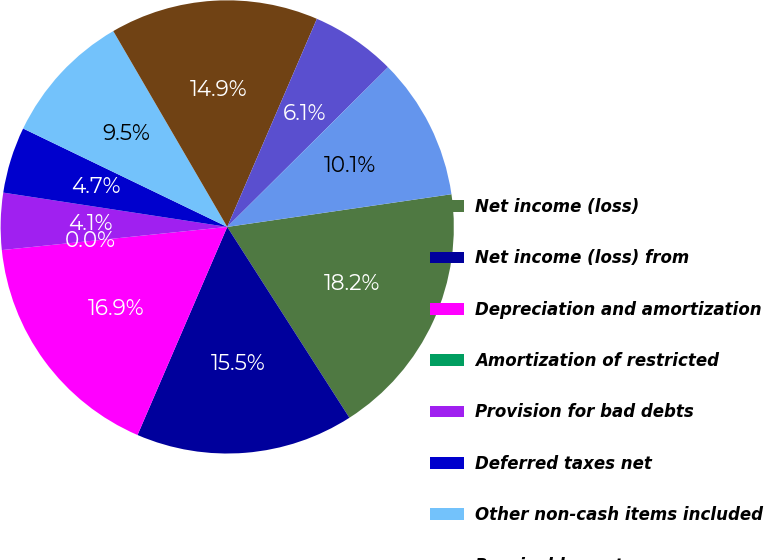<chart> <loc_0><loc_0><loc_500><loc_500><pie_chart><fcel>Net income (loss)<fcel>Net income (loss) from<fcel>Depreciation and amortization<fcel>Amortization of restricted<fcel>Provision for bad debts<fcel>Deferred taxes net<fcel>Other non-cash items included<fcel>Receivables net<fcel>Receivables from related<fcel>Other assets<nl><fcel>18.24%<fcel>15.54%<fcel>16.89%<fcel>0.0%<fcel>4.05%<fcel>4.73%<fcel>9.46%<fcel>14.86%<fcel>6.08%<fcel>10.14%<nl></chart> 